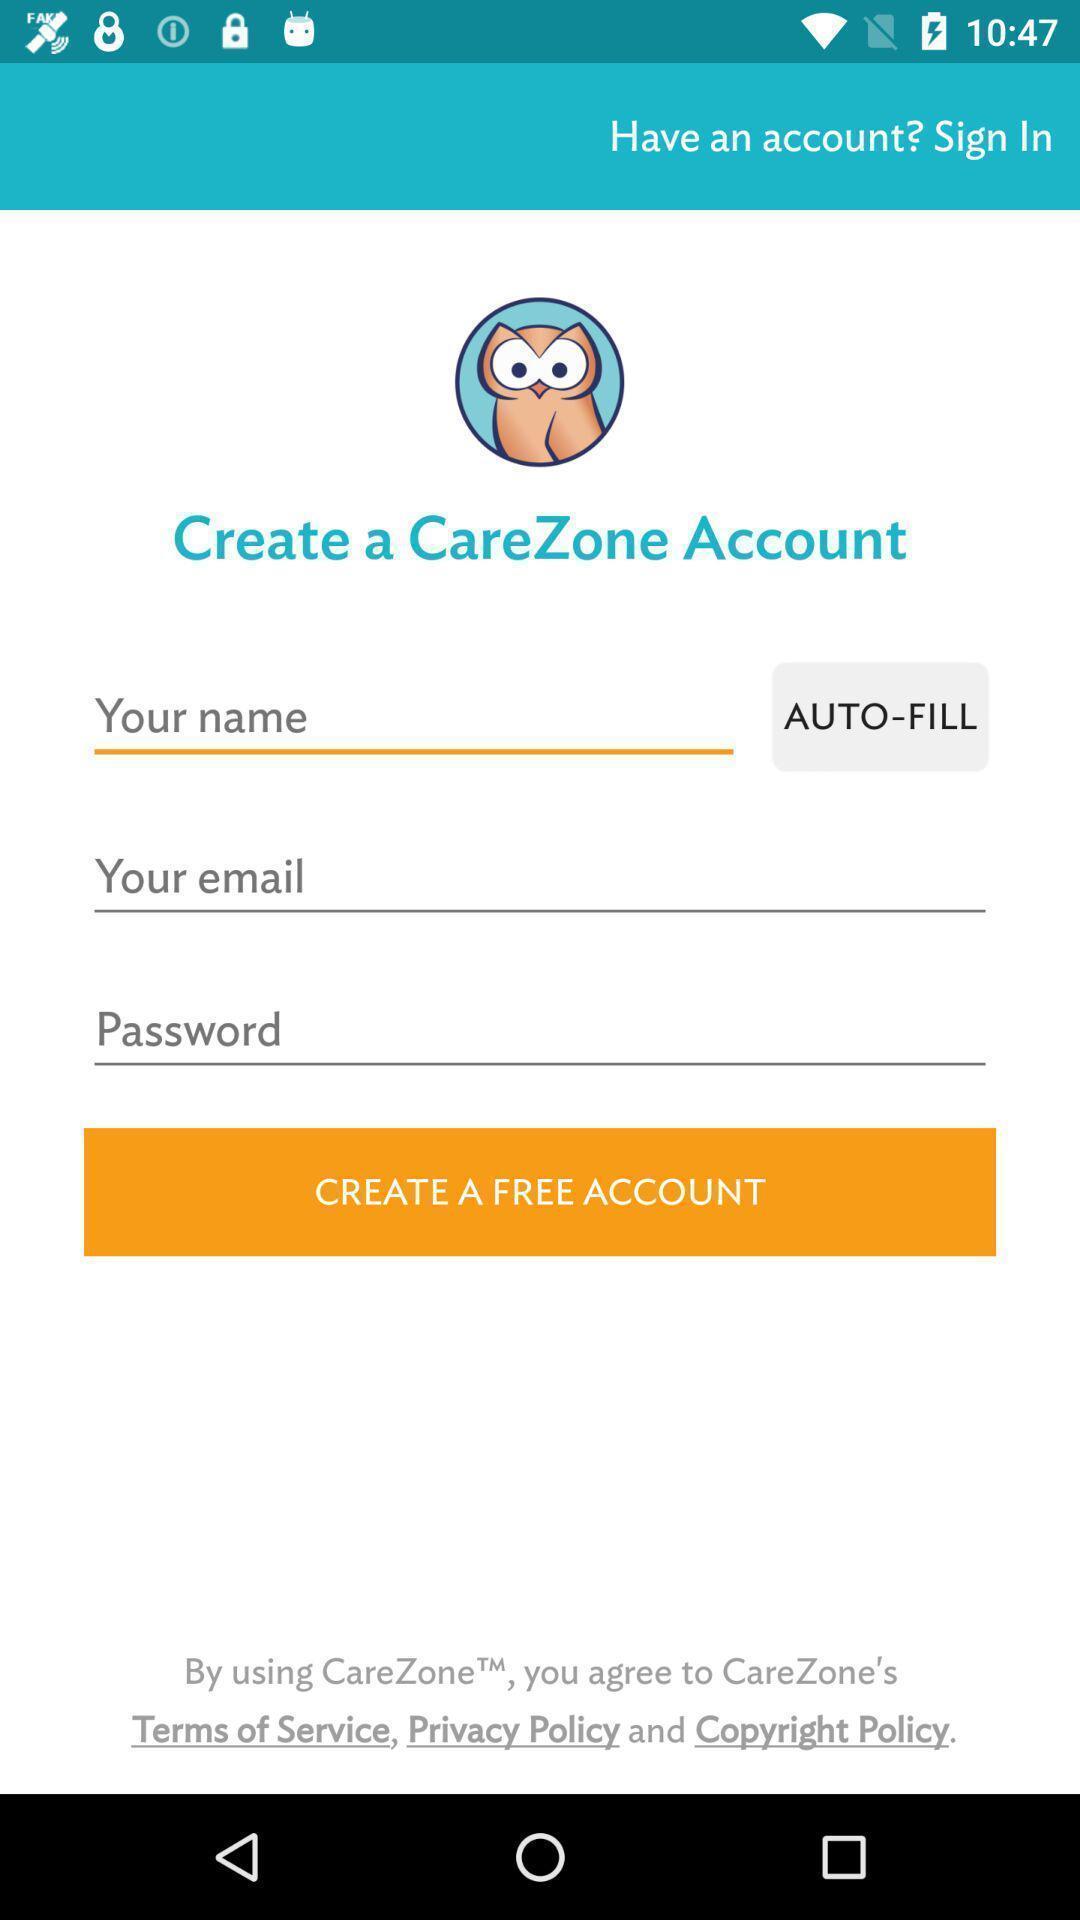Describe the key features of this screenshot. Screen showing create account page. 